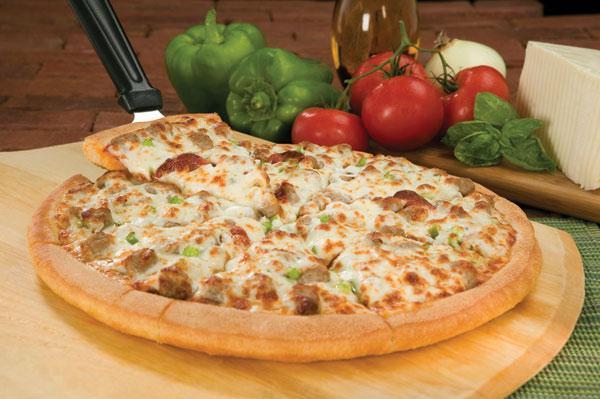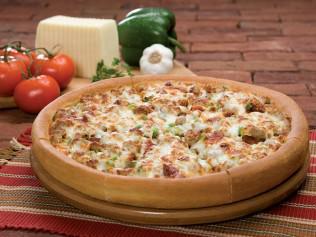The first image is the image on the left, the second image is the image on the right. For the images shown, is this caption "At least one of the pizzas has sliced olives on it." true? Answer yes or no. No. The first image is the image on the left, the second image is the image on the right. For the images shown, is this caption "There are two round full pizzas." true? Answer yes or no. Yes. 